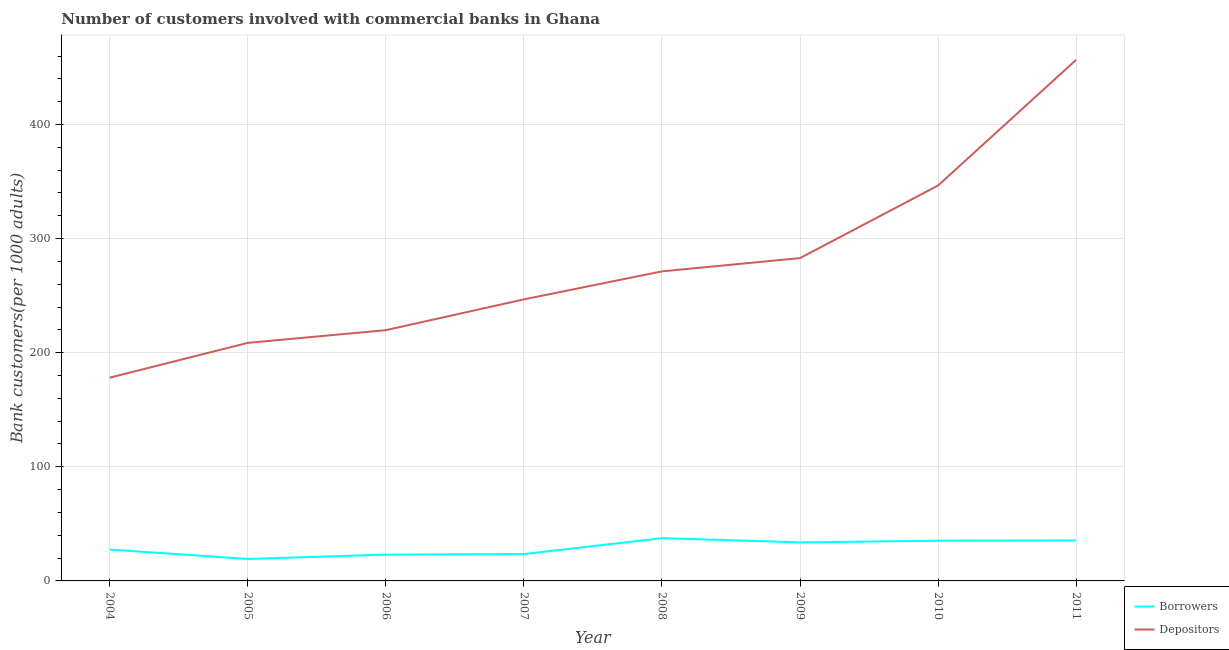What is the number of borrowers in 2009?
Offer a terse response. 33.76. Across all years, what is the maximum number of borrowers?
Your answer should be very brief. 37.48. Across all years, what is the minimum number of borrowers?
Provide a succinct answer. 19.23. In which year was the number of depositors minimum?
Keep it short and to the point. 2004. What is the total number of depositors in the graph?
Offer a terse response. 2210.68. What is the difference between the number of depositors in 2004 and that in 2009?
Give a very brief answer. -104.77. What is the difference between the number of depositors in 2011 and the number of borrowers in 2008?
Ensure brevity in your answer.  419.19. What is the average number of depositors per year?
Give a very brief answer. 276.34. In the year 2008, what is the difference between the number of depositors and number of borrowers?
Your answer should be compact. 233.8. What is the ratio of the number of borrowers in 2004 to that in 2011?
Make the answer very short. 0.78. What is the difference between the highest and the second highest number of depositors?
Provide a succinct answer. 110.13. What is the difference between the highest and the lowest number of depositors?
Keep it short and to the point. 278.53. Does the number of depositors monotonically increase over the years?
Your answer should be very brief. Yes. How many years are there in the graph?
Make the answer very short. 8. Are the values on the major ticks of Y-axis written in scientific E-notation?
Keep it short and to the point. No. What is the title of the graph?
Your answer should be very brief. Number of customers involved with commercial banks in Ghana. Does "Private funds" appear as one of the legend labels in the graph?
Your answer should be compact. No. What is the label or title of the Y-axis?
Give a very brief answer. Bank customers(per 1000 adults). What is the Bank customers(per 1000 adults) in Borrowers in 2004?
Your answer should be compact. 27.51. What is the Bank customers(per 1000 adults) in Depositors in 2004?
Provide a succinct answer. 178.14. What is the Bank customers(per 1000 adults) in Borrowers in 2005?
Offer a terse response. 19.23. What is the Bank customers(per 1000 adults) of Depositors in 2005?
Provide a succinct answer. 208.62. What is the Bank customers(per 1000 adults) in Borrowers in 2006?
Offer a very short reply. 23.06. What is the Bank customers(per 1000 adults) in Depositors in 2006?
Keep it short and to the point. 219.76. What is the Bank customers(per 1000 adults) of Borrowers in 2007?
Give a very brief answer. 23.53. What is the Bank customers(per 1000 adults) in Depositors in 2007?
Make the answer very short. 246.75. What is the Bank customers(per 1000 adults) in Borrowers in 2008?
Make the answer very short. 37.48. What is the Bank customers(per 1000 adults) in Depositors in 2008?
Offer a very short reply. 271.28. What is the Bank customers(per 1000 adults) in Borrowers in 2009?
Provide a short and direct response. 33.76. What is the Bank customers(per 1000 adults) of Depositors in 2009?
Give a very brief answer. 282.91. What is the Bank customers(per 1000 adults) of Borrowers in 2010?
Give a very brief answer. 35.26. What is the Bank customers(per 1000 adults) of Depositors in 2010?
Your response must be concise. 346.55. What is the Bank customers(per 1000 adults) of Borrowers in 2011?
Your response must be concise. 35.5. What is the Bank customers(per 1000 adults) of Depositors in 2011?
Offer a terse response. 456.67. Across all years, what is the maximum Bank customers(per 1000 adults) in Borrowers?
Offer a terse response. 37.48. Across all years, what is the maximum Bank customers(per 1000 adults) in Depositors?
Ensure brevity in your answer.  456.67. Across all years, what is the minimum Bank customers(per 1000 adults) in Borrowers?
Ensure brevity in your answer.  19.23. Across all years, what is the minimum Bank customers(per 1000 adults) of Depositors?
Provide a succinct answer. 178.14. What is the total Bank customers(per 1000 adults) in Borrowers in the graph?
Keep it short and to the point. 235.33. What is the total Bank customers(per 1000 adults) of Depositors in the graph?
Provide a short and direct response. 2210.68. What is the difference between the Bank customers(per 1000 adults) of Borrowers in 2004 and that in 2005?
Give a very brief answer. 8.29. What is the difference between the Bank customers(per 1000 adults) of Depositors in 2004 and that in 2005?
Keep it short and to the point. -30.48. What is the difference between the Bank customers(per 1000 adults) in Borrowers in 2004 and that in 2006?
Give a very brief answer. 4.45. What is the difference between the Bank customers(per 1000 adults) of Depositors in 2004 and that in 2006?
Offer a terse response. -41.62. What is the difference between the Bank customers(per 1000 adults) in Borrowers in 2004 and that in 2007?
Your answer should be compact. 3.99. What is the difference between the Bank customers(per 1000 adults) of Depositors in 2004 and that in 2007?
Ensure brevity in your answer.  -68.6. What is the difference between the Bank customers(per 1000 adults) of Borrowers in 2004 and that in 2008?
Make the answer very short. -9.97. What is the difference between the Bank customers(per 1000 adults) of Depositors in 2004 and that in 2008?
Your response must be concise. -93.14. What is the difference between the Bank customers(per 1000 adults) in Borrowers in 2004 and that in 2009?
Make the answer very short. -6.25. What is the difference between the Bank customers(per 1000 adults) in Depositors in 2004 and that in 2009?
Your answer should be compact. -104.77. What is the difference between the Bank customers(per 1000 adults) in Borrowers in 2004 and that in 2010?
Provide a succinct answer. -7.75. What is the difference between the Bank customers(per 1000 adults) in Depositors in 2004 and that in 2010?
Make the answer very short. -168.41. What is the difference between the Bank customers(per 1000 adults) in Borrowers in 2004 and that in 2011?
Keep it short and to the point. -7.99. What is the difference between the Bank customers(per 1000 adults) in Depositors in 2004 and that in 2011?
Offer a terse response. -278.53. What is the difference between the Bank customers(per 1000 adults) in Borrowers in 2005 and that in 2006?
Ensure brevity in your answer.  -3.84. What is the difference between the Bank customers(per 1000 adults) of Depositors in 2005 and that in 2006?
Ensure brevity in your answer.  -11.13. What is the difference between the Bank customers(per 1000 adults) of Borrowers in 2005 and that in 2007?
Give a very brief answer. -4.3. What is the difference between the Bank customers(per 1000 adults) in Depositors in 2005 and that in 2007?
Your response must be concise. -38.12. What is the difference between the Bank customers(per 1000 adults) in Borrowers in 2005 and that in 2008?
Your answer should be very brief. -18.26. What is the difference between the Bank customers(per 1000 adults) in Depositors in 2005 and that in 2008?
Provide a short and direct response. -62.66. What is the difference between the Bank customers(per 1000 adults) in Borrowers in 2005 and that in 2009?
Offer a very short reply. -14.54. What is the difference between the Bank customers(per 1000 adults) in Depositors in 2005 and that in 2009?
Offer a terse response. -74.29. What is the difference between the Bank customers(per 1000 adults) of Borrowers in 2005 and that in 2010?
Your response must be concise. -16.03. What is the difference between the Bank customers(per 1000 adults) in Depositors in 2005 and that in 2010?
Offer a terse response. -137.92. What is the difference between the Bank customers(per 1000 adults) of Borrowers in 2005 and that in 2011?
Make the answer very short. -16.27. What is the difference between the Bank customers(per 1000 adults) of Depositors in 2005 and that in 2011?
Provide a succinct answer. -248.05. What is the difference between the Bank customers(per 1000 adults) of Borrowers in 2006 and that in 2007?
Your answer should be compact. -0.46. What is the difference between the Bank customers(per 1000 adults) in Depositors in 2006 and that in 2007?
Make the answer very short. -26.99. What is the difference between the Bank customers(per 1000 adults) in Borrowers in 2006 and that in 2008?
Give a very brief answer. -14.42. What is the difference between the Bank customers(per 1000 adults) in Depositors in 2006 and that in 2008?
Offer a very short reply. -51.53. What is the difference between the Bank customers(per 1000 adults) of Borrowers in 2006 and that in 2009?
Offer a terse response. -10.7. What is the difference between the Bank customers(per 1000 adults) of Depositors in 2006 and that in 2009?
Ensure brevity in your answer.  -63.16. What is the difference between the Bank customers(per 1000 adults) in Borrowers in 2006 and that in 2010?
Offer a very short reply. -12.2. What is the difference between the Bank customers(per 1000 adults) in Depositors in 2006 and that in 2010?
Provide a succinct answer. -126.79. What is the difference between the Bank customers(per 1000 adults) in Borrowers in 2006 and that in 2011?
Provide a short and direct response. -12.44. What is the difference between the Bank customers(per 1000 adults) of Depositors in 2006 and that in 2011?
Provide a succinct answer. -236.92. What is the difference between the Bank customers(per 1000 adults) in Borrowers in 2007 and that in 2008?
Offer a terse response. -13.96. What is the difference between the Bank customers(per 1000 adults) in Depositors in 2007 and that in 2008?
Keep it short and to the point. -24.54. What is the difference between the Bank customers(per 1000 adults) in Borrowers in 2007 and that in 2009?
Give a very brief answer. -10.24. What is the difference between the Bank customers(per 1000 adults) in Depositors in 2007 and that in 2009?
Provide a succinct answer. -36.17. What is the difference between the Bank customers(per 1000 adults) in Borrowers in 2007 and that in 2010?
Your answer should be very brief. -11.73. What is the difference between the Bank customers(per 1000 adults) in Depositors in 2007 and that in 2010?
Provide a short and direct response. -99.8. What is the difference between the Bank customers(per 1000 adults) in Borrowers in 2007 and that in 2011?
Keep it short and to the point. -11.97. What is the difference between the Bank customers(per 1000 adults) of Depositors in 2007 and that in 2011?
Give a very brief answer. -209.93. What is the difference between the Bank customers(per 1000 adults) in Borrowers in 2008 and that in 2009?
Keep it short and to the point. 3.72. What is the difference between the Bank customers(per 1000 adults) in Depositors in 2008 and that in 2009?
Ensure brevity in your answer.  -11.63. What is the difference between the Bank customers(per 1000 adults) of Borrowers in 2008 and that in 2010?
Ensure brevity in your answer.  2.22. What is the difference between the Bank customers(per 1000 adults) in Depositors in 2008 and that in 2010?
Offer a terse response. -75.26. What is the difference between the Bank customers(per 1000 adults) of Borrowers in 2008 and that in 2011?
Keep it short and to the point. 1.98. What is the difference between the Bank customers(per 1000 adults) of Depositors in 2008 and that in 2011?
Provide a short and direct response. -185.39. What is the difference between the Bank customers(per 1000 adults) in Borrowers in 2009 and that in 2010?
Offer a very short reply. -1.5. What is the difference between the Bank customers(per 1000 adults) in Depositors in 2009 and that in 2010?
Ensure brevity in your answer.  -63.63. What is the difference between the Bank customers(per 1000 adults) in Borrowers in 2009 and that in 2011?
Give a very brief answer. -1.74. What is the difference between the Bank customers(per 1000 adults) in Depositors in 2009 and that in 2011?
Your answer should be very brief. -173.76. What is the difference between the Bank customers(per 1000 adults) in Borrowers in 2010 and that in 2011?
Make the answer very short. -0.24. What is the difference between the Bank customers(per 1000 adults) of Depositors in 2010 and that in 2011?
Your answer should be compact. -110.13. What is the difference between the Bank customers(per 1000 adults) in Borrowers in 2004 and the Bank customers(per 1000 adults) in Depositors in 2005?
Give a very brief answer. -181.11. What is the difference between the Bank customers(per 1000 adults) in Borrowers in 2004 and the Bank customers(per 1000 adults) in Depositors in 2006?
Provide a succinct answer. -192.24. What is the difference between the Bank customers(per 1000 adults) in Borrowers in 2004 and the Bank customers(per 1000 adults) in Depositors in 2007?
Keep it short and to the point. -219.23. What is the difference between the Bank customers(per 1000 adults) in Borrowers in 2004 and the Bank customers(per 1000 adults) in Depositors in 2008?
Provide a short and direct response. -243.77. What is the difference between the Bank customers(per 1000 adults) of Borrowers in 2004 and the Bank customers(per 1000 adults) of Depositors in 2009?
Keep it short and to the point. -255.4. What is the difference between the Bank customers(per 1000 adults) in Borrowers in 2004 and the Bank customers(per 1000 adults) in Depositors in 2010?
Your answer should be very brief. -319.03. What is the difference between the Bank customers(per 1000 adults) in Borrowers in 2004 and the Bank customers(per 1000 adults) in Depositors in 2011?
Your response must be concise. -429.16. What is the difference between the Bank customers(per 1000 adults) in Borrowers in 2005 and the Bank customers(per 1000 adults) in Depositors in 2006?
Your answer should be compact. -200.53. What is the difference between the Bank customers(per 1000 adults) in Borrowers in 2005 and the Bank customers(per 1000 adults) in Depositors in 2007?
Provide a succinct answer. -227.52. What is the difference between the Bank customers(per 1000 adults) in Borrowers in 2005 and the Bank customers(per 1000 adults) in Depositors in 2008?
Give a very brief answer. -252.06. What is the difference between the Bank customers(per 1000 adults) of Borrowers in 2005 and the Bank customers(per 1000 adults) of Depositors in 2009?
Keep it short and to the point. -263.69. What is the difference between the Bank customers(per 1000 adults) of Borrowers in 2005 and the Bank customers(per 1000 adults) of Depositors in 2010?
Provide a succinct answer. -327.32. What is the difference between the Bank customers(per 1000 adults) of Borrowers in 2005 and the Bank customers(per 1000 adults) of Depositors in 2011?
Give a very brief answer. -437.45. What is the difference between the Bank customers(per 1000 adults) in Borrowers in 2006 and the Bank customers(per 1000 adults) in Depositors in 2007?
Your answer should be very brief. -223.68. What is the difference between the Bank customers(per 1000 adults) of Borrowers in 2006 and the Bank customers(per 1000 adults) of Depositors in 2008?
Provide a short and direct response. -248.22. What is the difference between the Bank customers(per 1000 adults) of Borrowers in 2006 and the Bank customers(per 1000 adults) of Depositors in 2009?
Your answer should be very brief. -259.85. What is the difference between the Bank customers(per 1000 adults) of Borrowers in 2006 and the Bank customers(per 1000 adults) of Depositors in 2010?
Offer a very short reply. -323.48. What is the difference between the Bank customers(per 1000 adults) of Borrowers in 2006 and the Bank customers(per 1000 adults) of Depositors in 2011?
Your response must be concise. -433.61. What is the difference between the Bank customers(per 1000 adults) of Borrowers in 2007 and the Bank customers(per 1000 adults) of Depositors in 2008?
Offer a terse response. -247.76. What is the difference between the Bank customers(per 1000 adults) in Borrowers in 2007 and the Bank customers(per 1000 adults) in Depositors in 2009?
Offer a very short reply. -259.39. What is the difference between the Bank customers(per 1000 adults) of Borrowers in 2007 and the Bank customers(per 1000 adults) of Depositors in 2010?
Your answer should be compact. -323.02. What is the difference between the Bank customers(per 1000 adults) in Borrowers in 2007 and the Bank customers(per 1000 adults) in Depositors in 2011?
Provide a short and direct response. -433.15. What is the difference between the Bank customers(per 1000 adults) in Borrowers in 2008 and the Bank customers(per 1000 adults) in Depositors in 2009?
Your answer should be very brief. -245.43. What is the difference between the Bank customers(per 1000 adults) of Borrowers in 2008 and the Bank customers(per 1000 adults) of Depositors in 2010?
Offer a terse response. -309.06. What is the difference between the Bank customers(per 1000 adults) of Borrowers in 2008 and the Bank customers(per 1000 adults) of Depositors in 2011?
Provide a succinct answer. -419.19. What is the difference between the Bank customers(per 1000 adults) of Borrowers in 2009 and the Bank customers(per 1000 adults) of Depositors in 2010?
Provide a succinct answer. -312.78. What is the difference between the Bank customers(per 1000 adults) of Borrowers in 2009 and the Bank customers(per 1000 adults) of Depositors in 2011?
Give a very brief answer. -422.91. What is the difference between the Bank customers(per 1000 adults) in Borrowers in 2010 and the Bank customers(per 1000 adults) in Depositors in 2011?
Offer a terse response. -421.41. What is the average Bank customers(per 1000 adults) of Borrowers per year?
Provide a short and direct response. 29.42. What is the average Bank customers(per 1000 adults) in Depositors per year?
Your answer should be very brief. 276.34. In the year 2004, what is the difference between the Bank customers(per 1000 adults) in Borrowers and Bank customers(per 1000 adults) in Depositors?
Offer a very short reply. -150.63. In the year 2005, what is the difference between the Bank customers(per 1000 adults) in Borrowers and Bank customers(per 1000 adults) in Depositors?
Provide a short and direct response. -189.4. In the year 2006, what is the difference between the Bank customers(per 1000 adults) in Borrowers and Bank customers(per 1000 adults) in Depositors?
Provide a short and direct response. -196.69. In the year 2007, what is the difference between the Bank customers(per 1000 adults) in Borrowers and Bank customers(per 1000 adults) in Depositors?
Your response must be concise. -223.22. In the year 2008, what is the difference between the Bank customers(per 1000 adults) in Borrowers and Bank customers(per 1000 adults) in Depositors?
Offer a terse response. -233.8. In the year 2009, what is the difference between the Bank customers(per 1000 adults) in Borrowers and Bank customers(per 1000 adults) in Depositors?
Your answer should be very brief. -249.15. In the year 2010, what is the difference between the Bank customers(per 1000 adults) of Borrowers and Bank customers(per 1000 adults) of Depositors?
Give a very brief answer. -311.29. In the year 2011, what is the difference between the Bank customers(per 1000 adults) of Borrowers and Bank customers(per 1000 adults) of Depositors?
Your response must be concise. -421.17. What is the ratio of the Bank customers(per 1000 adults) of Borrowers in 2004 to that in 2005?
Your answer should be compact. 1.43. What is the ratio of the Bank customers(per 1000 adults) in Depositors in 2004 to that in 2005?
Ensure brevity in your answer.  0.85. What is the ratio of the Bank customers(per 1000 adults) in Borrowers in 2004 to that in 2006?
Ensure brevity in your answer.  1.19. What is the ratio of the Bank customers(per 1000 adults) in Depositors in 2004 to that in 2006?
Make the answer very short. 0.81. What is the ratio of the Bank customers(per 1000 adults) of Borrowers in 2004 to that in 2007?
Offer a very short reply. 1.17. What is the ratio of the Bank customers(per 1000 adults) of Depositors in 2004 to that in 2007?
Keep it short and to the point. 0.72. What is the ratio of the Bank customers(per 1000 adults) in Borrowers in 2004 to that in 2008?
Provide a short and direct response. 0.73. What is the ratio of the Bank customers(per 1000 adults) of Depositors in 2004 to that in 2008?
Offer a terse response. 0.66. What is the ratio of the Bank customers(per 1000 adults) of Borrowers in 2004 to that in 2009?
Give a very brief answer. 0.81. What is the ratio of the Bank customers(per 1000 adults) of Depositors in 2004 to that in 2009?
Ensure brevity in your answer.  0.63. What is the ratio of the Bank customers(per 1000 adults) of Borrowers in 2004 to that in 2010?
Offer a very short reply. 0.78. What is the ratio of the Bank customers(per 1000 adults) of Depositors in 2004 to that in 2010?
Keep it short and to the point. 0.51. What is the ratio of the Bank customers(per 1000 adults) in Borrowers in 2004 to that in 2011?
Offer a very short reply. 0.78. What is the ratio of the Bank customers(per 1000 adults) of Depositors in 2004 to that in 2011?
Make the answer very short. 0.39. What is the ratio of the Bank customers(per 1000 adults) in Borrowers in 2005 to that in 2006?
Your response must be concise. 0.83. What is the ratio of the Bank customers(per 1000 adults) in Depositors in 2005 to that in 2006?
Make the answer very short. 0.95. What is the ratio of the Bank customers(per 1000 adults) in Borrowers in 2005 to that in 2007?
Provide a succinct answer. 0.82. What is the ratio of the Bank customers(per 1000 adults) in Depositors in 2005 to that in 2007?
Your response must be concise. 0.85. What is the ratio of the Bank customers(per 1000 adults) in Borrowers in 2005 to that in 2008?
Offer a very short reply. 0.51. What is the ratio of the Bank customers(per 1000 adults) of Depositors in 2005 to that in 2008?
Keep it short and to the point. 0.77. What is the ratio of the Bank customers(per 1000 adults) of Borrowers in 2005 to that in 2009?
Make the answer very short. 0.57. What is the ratio of the Bank customers(per 1000 adults) in Depositors in 2005 to that in 2009?
Keep it short and to the point. 0.74. What is the ratio of the Bank customers(per 1000 adults) of Borrowers in 2005 to that in 2010?
Your answer should be compact. 0.55. What is the ratio of the Bank customers(per 1000 adults) in Depositors in 2005 to that in 2010?
Offer a very short reply. 0.6. What is the ratio of the Bank customers(per 1000 adults) in Borrowers in 2005 to that in 2011?
Your response must be concise. 0.54. What is the ratio of the Bank customers(per 1000 adults) of Depositors in 2005 to that in 2011?
Provide a short and direct response. 0.46. What is the ratio of the Bank customers(per 1000 adults) in Borrowers in 2006 to that in 2007?
Provide a succinct answer. 0.98. What is the ratio of the Bank customers(per 1000 adults) of Depositors in 2006 to that in 2007?
Make the answer very short. 0.89. What is the ratio of the Bank customers(per 1000 adults) of Borrowers in 2006 to that in 2008?
Ensure brevity in your answer.  0.62. What is the ratio of the Bank customers(per 1000 adults) in Depositors in 2006 to that in 2008?
Offer a terse response. 0.81. What is the ratio of the Bank customers(per 1000 adults) of Borrowers in 2006 to that in 2009?
Provide a succinct answer. 0.68. What is the ratio of the Bank customers(per 1000 adults) in Depositors in 2006 to that in 2009?
Your answer should be compact. 0.78. What is the ratio of the Bank customers(per 1000 adults) of Borrowers in 2006 to that in 2010?
Your answer should be very brief. 0.65. What is the ratio of the Bank customers(per 1000 adults) in Depositors in 2006 to that in 2010?
Offer a terse response. 0.63. What is the ratio of the Bank customers(per 1000 adults) in Borrowers in 2006 to that in 2011?
Your answer should be very brief. 0.65. What is the ratio of the Bank customers(per 1000 adults) in Depositors in 2006 to that in 2011?
Your response must be concise. 0.48. What is the ratio of the Bank customers(per 1000 adults) in Borrowers in 2007 to that in 2008?
Your response must be concise. 0.63. What is the ratio of the Bank customers(per 1000 adults) in Depositors in 2007 to that in 2008?
Provide a short and direct response. 0.91. What is the ratio of the Bank customers(per 1000 adults) in Borrowers in 2007 to that in 2009?
Your answer should be compact. 0.7. What is the ratio of the Bank customers(per 1000 adults) in Depositors in 2007 to that in 2009?
Offer a very short reply. 0.87. What is the ratio of the Bank customers(per 1000 adults) of Borrowers in 2007 to that in 2010?
Give a very brief answer. 0.67. What is the ratio of the Bank customers(per 1000 adults) in Depositors in 2007 to that in 2010?
Keep it short and to the point. 0.71. What is the ratio of the Bank customers(per 1000 adults) in Borrowers in 2007 to that in 2011?
Your answer should be compact. 0.66. What is the ratio of the Bank customers(per 1000 adults) of Depositors in 2007 to that in 2011?
Keep it short and to the point. 0.54. What is the ratio of the Bank customers(per 1000 adults) in Borrowers in 2008 to that in 2009?
Provide a succinct answer. 1.11. What is the ratio of the Bank customers(per 1000 adults) in Depositors in 2008 to that in 2009?
Your response must be concise. 0.96. What is the ratio of the Bank customers(per 1000 adults) of Borrowers in 2008 to that in 2010?
Offer a terse response. 1.06. What is the ratio of the Bank customers(per 1000 adults) of Depositors in 2008 to that in 2010?
Your answer should be very brief. 0.78. What is the ratio of the Bank customers(per 1000 adults) of Borrowers in 2008 to that in 2011?
Your answer should be compact. 1.06. What is the ratio of the Bank customers(per 1000 adults) of Depositors in 2008 to that in 2011?
Your answer should be compact. 0.59. What is the ratio of the Bank customers(per 1000 adults) in Borrowers in 2009 to that in 2010?
Your response must be concise. 0.96. What is the ratio of the Bank customers(per 1000 adults) in Depositors in 2009 to that in 2010?
Your response must be concise. 0.82. What is the ratio of the Bank customers(per 1000 adults) in Borrowers in 2009 to that in 2011?
Ensure brevity in your answer.  0.95. What is the ratio of the Bank customers(per 1000 adults) in Depositors in 2009 to that in 2011?
Provide a short and direct response. 0.62. What is the ratio of the Bank customers(per 1000 adults) of Borrowers in 2010 to that in 2011?
Ensure brevity in your answer.  0.99. What is the ratio of the Bank customers(per 1000 adults) of Depositors in 2010 to that in 2011?
Give a very brief answer. 0.76. What is the difference between the highest and the second highest Bank customers(per 1000 adults) in Borrowers?
Your answer should be very brief. 1.98. What is the difference between the highest and the second highest Bank customers(per 1000 adults) of Depositors?
Offer a very short reply. 110.13. What is the difference between the highest and the lowest Bank customers(per 1000 adults) in Borrowers?
Ensure brevity in your answer.  18.26. What is the difference between the highest and the lowest Bank customers(per 1000 adults) in Depositors?
Your response must be concise. 278.53. 